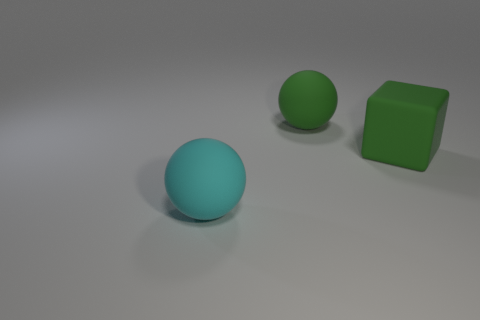Add 2 big green cubes. How many objects exist? 5 Subtract 1 balls. How many balls are left? 1 Subtract all green spheres. How many spheres are left? 1 Subtract 1 green cubes. How many objects are left? 2 Subtract all spheres. How many objects are left? 1 Subtract all brown spheres. Subtract all red blocks. How many spheres are left? 2 Subtract all gray cylinders. How many green balls are left? 1 Subtract all rubber spheres. Subtract all large green metal cylinders. How many objects are left? 1 Add 1 green things. How many green things are left? 3 Add 1 big purple shiny spheres. How many big purple shiny spheres exist? 1 